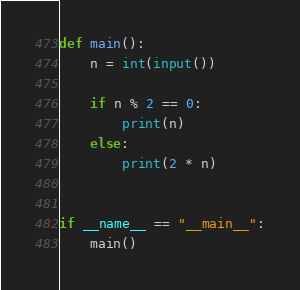Convert code to text. <code><loc_0><loc_0><loc_500><loc_500><_Python_>def main():
    n = int(input())

    if n % 2 == 0:
        print(n)
    else:
        print(2 * n)


if __name__ == "__main__":
    main()
</code> 